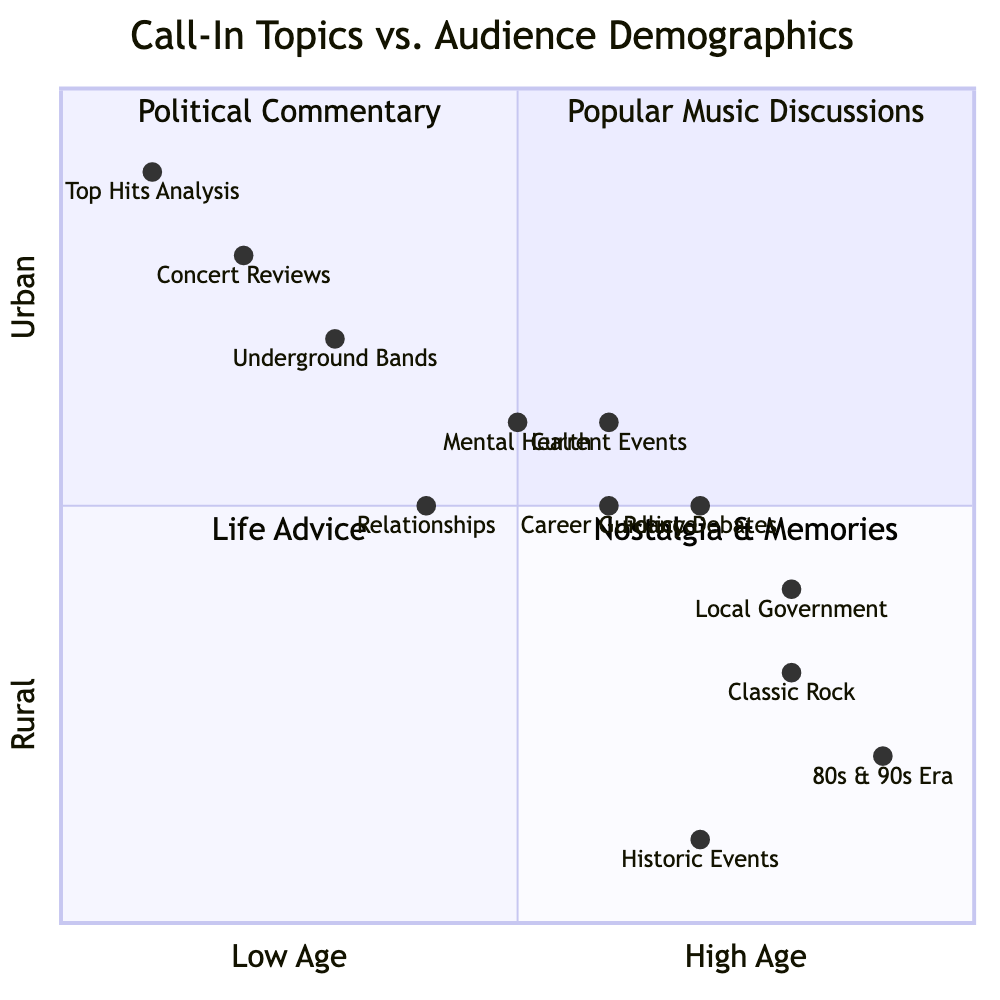What call-in topic is associated with the youngest audience demographic? The youngest audience demographic is 18-25, which corresponds to the quadrant labeled "Popular Music Discussions." The call-in topics in this quadrant include "Concert Reviews," "Top Hits Analysis," and "Underground Bands."
Answer: Popular Music Discussions How many total call-in topics are listed in the quadrant for Nostalgia & Memories? The quadrant for "Nostalgia & Memories" includes three call-in topics: "80s & 90s Era," "Classic Rock," and "Historic Events." Therefore, the total number of call-in topics listed in this quadrant is three.
Answer: 3 Which call-in topic is most relevant to professionals aged 35-50? The call-in topics that are most relevant to the audience demographic of professionals aged 35-50 are found in the "Political Commentary" quadrant. The topics listed there are "Current Events," "Policy Debates," and "Local Government."
Answer: Political Commentary In which quadrant do the majority of call-in topics focus on mental health and relationships? The topics related to mental health and relationships are found in the "Life Advice" quadrant, which includes topics like "Relationships," "Mental Health," and "Career Guidance." This quadrant caters to younger professionals.
Answer: Life Advice What is the demographic range of the audience for the "Nostalgia & Memories" quadrant? The demographic range of the audience for the "Nostalgia & Memories" quadrant is primarily "45-65." This is specified in the audience demographics for that section of the chart.
Answer: 45-65 Which quadrant includes discussions about underground bands? The discussions about underground bands are located in the "Popular Music Discussions" quadrant, which focuses on various musical themes, particularly aimed at a younger audience demographic.
Answer: Popular Music Discussions What call-in topic appears to target the 25-40 age group? The "Life Advice" quadrant includes a focus on topics that resonate well with the 25-40 age group, specifically "Relationships," "Mental Health," and "Career Guidance."
Answer: Life Advice How does the political commentary audience typically differ from the nostalgia audience? The audience for political commentary is primarily aged 35-50 and includes professionals living in suburban areas, while the nostalgia audience is mainly aged 45-65, consisting of baby boomers in rural areas.
Answer: Age and location differences Which call-in topic is likely to engage an urban audience? The call-in topics in the "Popular Music Discussions" quadrant are likely to engage an urban audience, with topics such as "Concert Reviews," "Top Hits Analysis," and "Underground Bands," appealing to those demographics.
Answer: Popular Music Discussions 